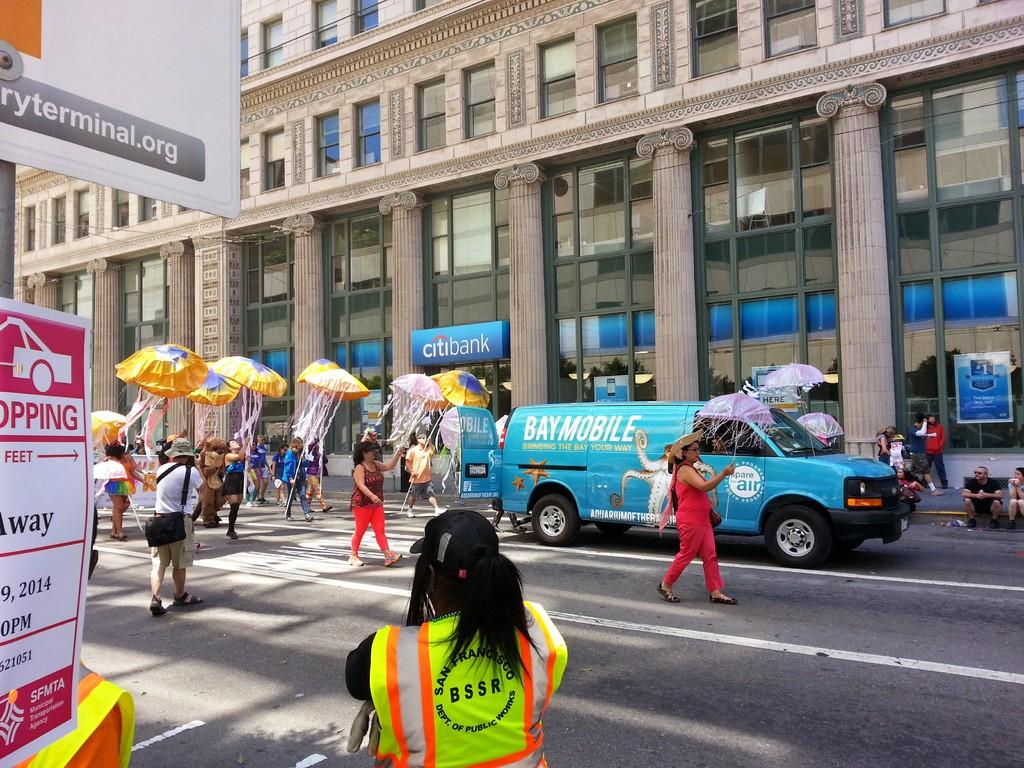What company is on the blue van?
Your answer should be compact. Baymobile. 